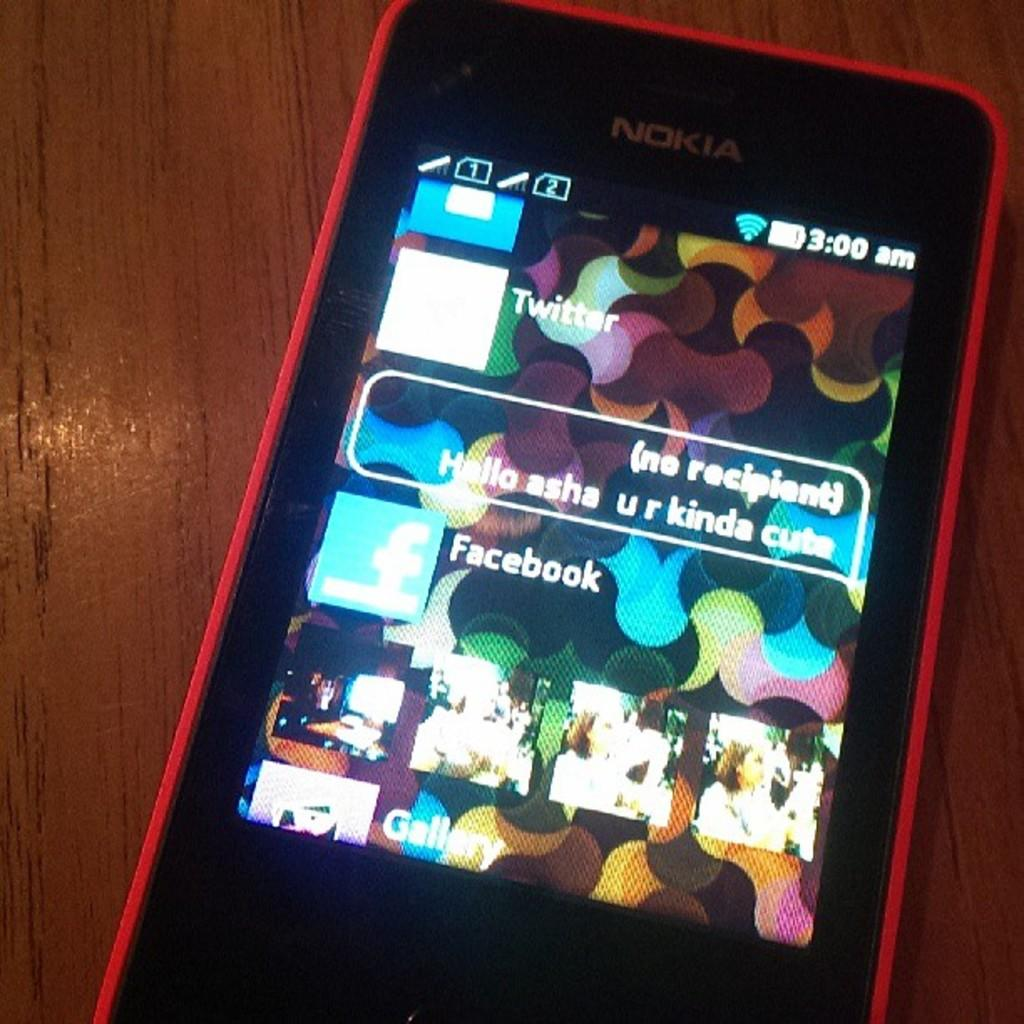What object is present in the image? There is a phone in the image. What is the phone resting on? The phone is on a wooden surface. What type of sign can be seen in the image? There is no sign present in the image; it only features a phone on a wooden surface. What sound does the thunder make in the image? There is no thunder present in the image; it only features a phone on a wooden surface. 